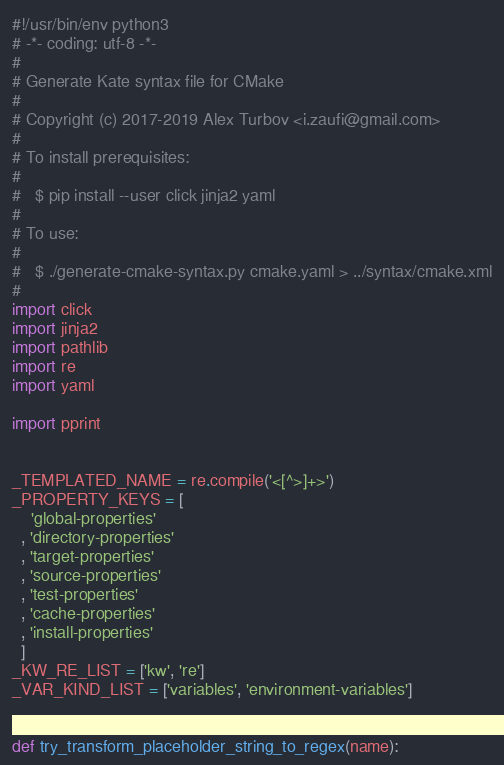Convert code to text. <code><loc_0><loc_0><loc_500><loc_500><_Python_>#!/usr/bin/env python3
# -*- coding: utf-8 -*-
#
# Generate Kate syntax file for CMake
#
# Copyright (c) 2017-2019 Alex Turbov <i.zaufi@gmail.com>
#
# To install prerequisites:
#
#   $ pip install --user click jinja2 yaml
#
# To use:
#
#   $ ./generate-cmake-syntax.py cmake.yaml > ../syntax/cmake.xml
#
import click
import jinja2
import pathlib
import re
import yaml

import pprint


_TEMPLATED_NAME = re.compile('<[^>]+>')
_PROPERTY_KEYS = [
    'global-properties'
  , 'directory-properties'
  , 'target-properties'
  , 'source-properties'
  , 'test-properties'
  , 'cache-properties'
  , 'install-properties'
  ]
_KW_RE_LIST = ['kw', 're']
_VAR_KIND_LIST = ['variables', 'environment-variables']


def try_transform_placeholder_string_to_regex(name):</code> 